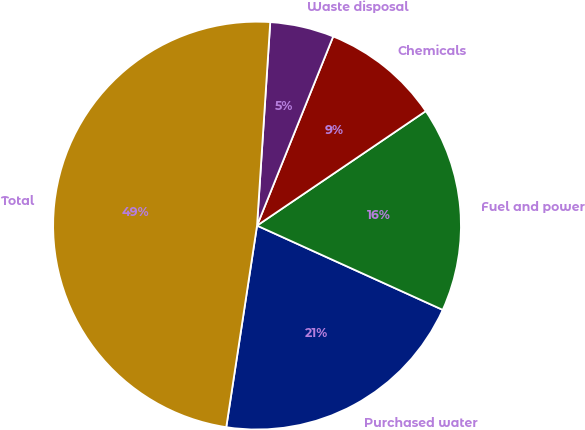Convert chart to OTSL. <chart><loc_0><loc_0><loc_500><loc_500><pie_chart><fcel>Purchased water<fcel>Fuel and power<fcel>Chemicals<fcel>Waste disposal<fcel>Total<nl><fcel>20.63%<fcel>16.27%<fcel>9.42%<fcel>5.06%<fcel>48.62%<nl></chart> 